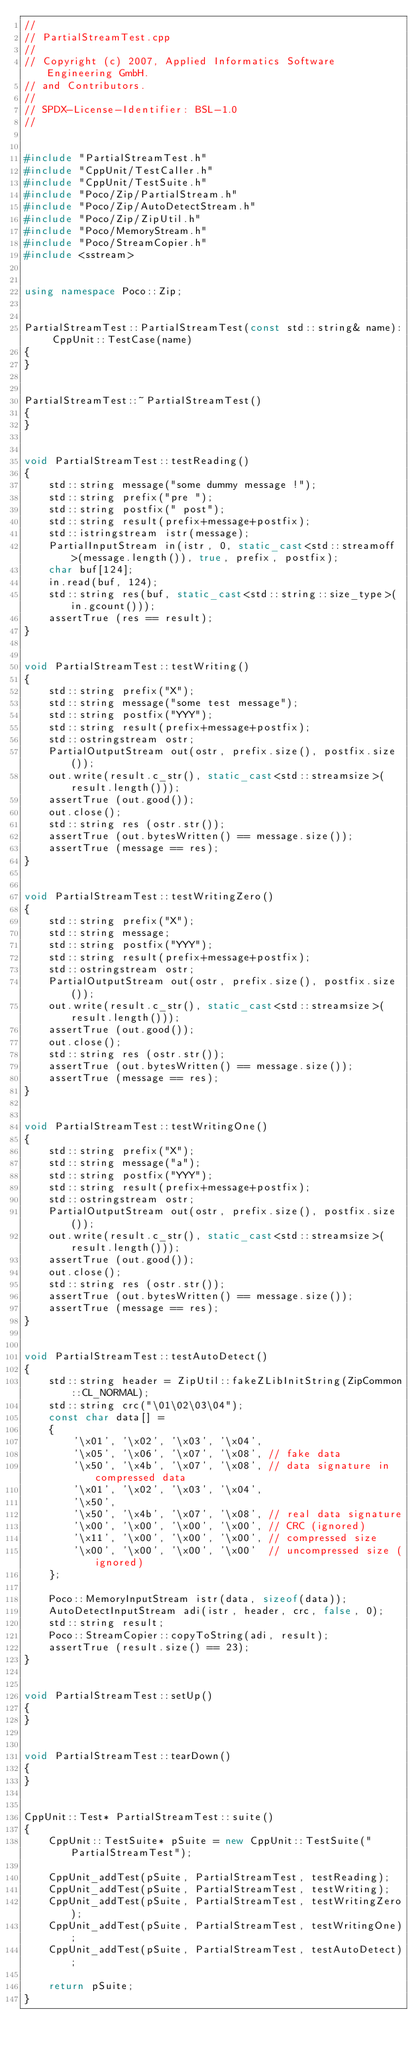Convert code to text. <code><loc_0><loc_0><loc_500><loc_500><_C++_>//
// PartialStreamTest.cpp
//
// Copyright (c) 2007, Applied Informatics Software Engineering GmbH.
// and Contributors.
//
// SPDX-License-Identifier:	BSL-1.0
//


#include "PartialStreamTest.h"
#include "CppUnit/TestCaller.h"
#include "CppUnit/TestSuite.h"
#include "Poco/Zip/PartialStream.h"
#include "Poco/Zip/AutoDetectStream.h"
#include "Poco/Zip/ZipUtil.h"
#include "Poco/MemoryStream.h"
#include "Poco/StreamCopier.h"
#include <sstream>


using namespace Poco::Zip;


PartialStreamTest::PartialStreamTest(const std::string& name): CppUnit::TestCase(name)
{
}


PartialStreamTest::~PartialStreamTest()
{
}


void PartialStreamTest::testReading()
{
	std::string message("some dummy message !");
	std::string prefix("pre ");
	std::string postfix(" post");
	std::string result(prefix+message+postfix);
	std::istringstream istr(message);
	PartialInputStream in(istr, 0, static_cast<std::streamoff>(message.length()), true, prefix, postfix);
	char buf[124];
	in.read(buf, 124);
	std::string res(buf, static_cast<std::string::size_type>(in.gcount()));
	assertTrue (res == result);
}


void PartialStreamTest::testWriting()
{
	std::string prefix("X");
	std::string message("some test message");
	std::string postfix("YYY");
	std::string result(prefix+message+postfix);
	std::ostringstream ostr;
	PartialOutputStream out(ostr, prefix.size(), postfix.size());
	out.write(result.c_str(), static_cast<std::streamsize>(result.length()));
	assertTrue (out.good());
	out.close();
	std::string res (ostr.str());
	assertTrue (out.bytesWritten() == message.size());
	assertTrue (message == res);
}


void PartialStreamTest::testWritingZero()
{
	std::string prefix("X");
	std::string message;
	std::string postfix("YYY");
	std::string result(prefix+message+postfix);
	std::ostringstream ostr;
	PartialOutputStream out(ostr, prefix.size(), postfix.size());
	out.write(result.c_str(), static_cast<std::streamsize>(result.length()));
	assertTrue (out.good());
	out.close();
	std::string res (ostr.str());
	assertTrue (out.bytesWritten() == message.size());
	assertTrue (message == res);
}


void PartialStreamTest::testWritingOne()
{
	std::string prefix("X");
	std::string message("a");
	std::string postfix("YYY");
	std::string result(prefix+message+postfix);
	std::ostringstream ostr;
	PartialOutputStream out(ostr, prefix.size(), postfix.size());
	out.write(result.c_str(), static_cast<std::streamsize>(result.length()));
	assertTrue (out.good());
	out.close();
	std::string res (ostr.str());
	assertTrue (out.bytesWritten() == message.size());
	assertTrue (message == res);
}


void PartialStreamTest::testAutoDetect()
{
	std::string header = ZipUtil::fakeZLibInitString(ZipCommon::CL_NORMAL);
	std::string crc("\01\02\03\04");
	const char data[] = 
	{
		'\x01', '\x02', '\x03', '\x04', 
		'\x05', '\x06', '\x07', '\x08', // fake data
		'\x50', '\x4b', '\x07', '\x08', // data signature in compressed data
		'\x01', '\x02', '\x03', '\x04',
		'\x50', 
		'\x50', '\x4b', '\x07', '\x08', // real data signature 
		'\x00', '\x00', '\x00', '\x00', // CRC (ignored)
		'\x11', '\x00', '\x00', '\x00', // compressed size
		'\x00', '\x00', '\x00', '\x00'  // uncompressed size (ignored)
	};
	
	Poco::MemoryInputStream istr(data, sizeof(data));
	AutoDetectInputStream adi(istr, header, crc, false, 0);
	std::string result;
	Poco::StreamCopier::copyToString(adi, result);
	assertTrue (result.size() == 23);
}


void PartialStreamTest::setUp()
{
}


void PartialStreamTest::tearDown()
{
}


CppUnit::Test* PartialStreamTest::suite()
{
	CppUnit::TestSuite* pSuite = new CppUnit::TestSuite("PartialStreamTest");

	CppUnit_addTest(pSuite, PartialStreamTest, testReading);
	CppUnit_addTest(pSuite, PartialStreamTest, testWriting);
	CppUnit_addTest(pSuite, PartialStreamTest, testWritingZero);
	CppUnit_addTest(pSuite, PartialStreamTest, testWritingOne);
	CppUnit_addTest(pSuite, PartialStreamTest, testAutoDetect);

	return pSuite;
}
</code> 